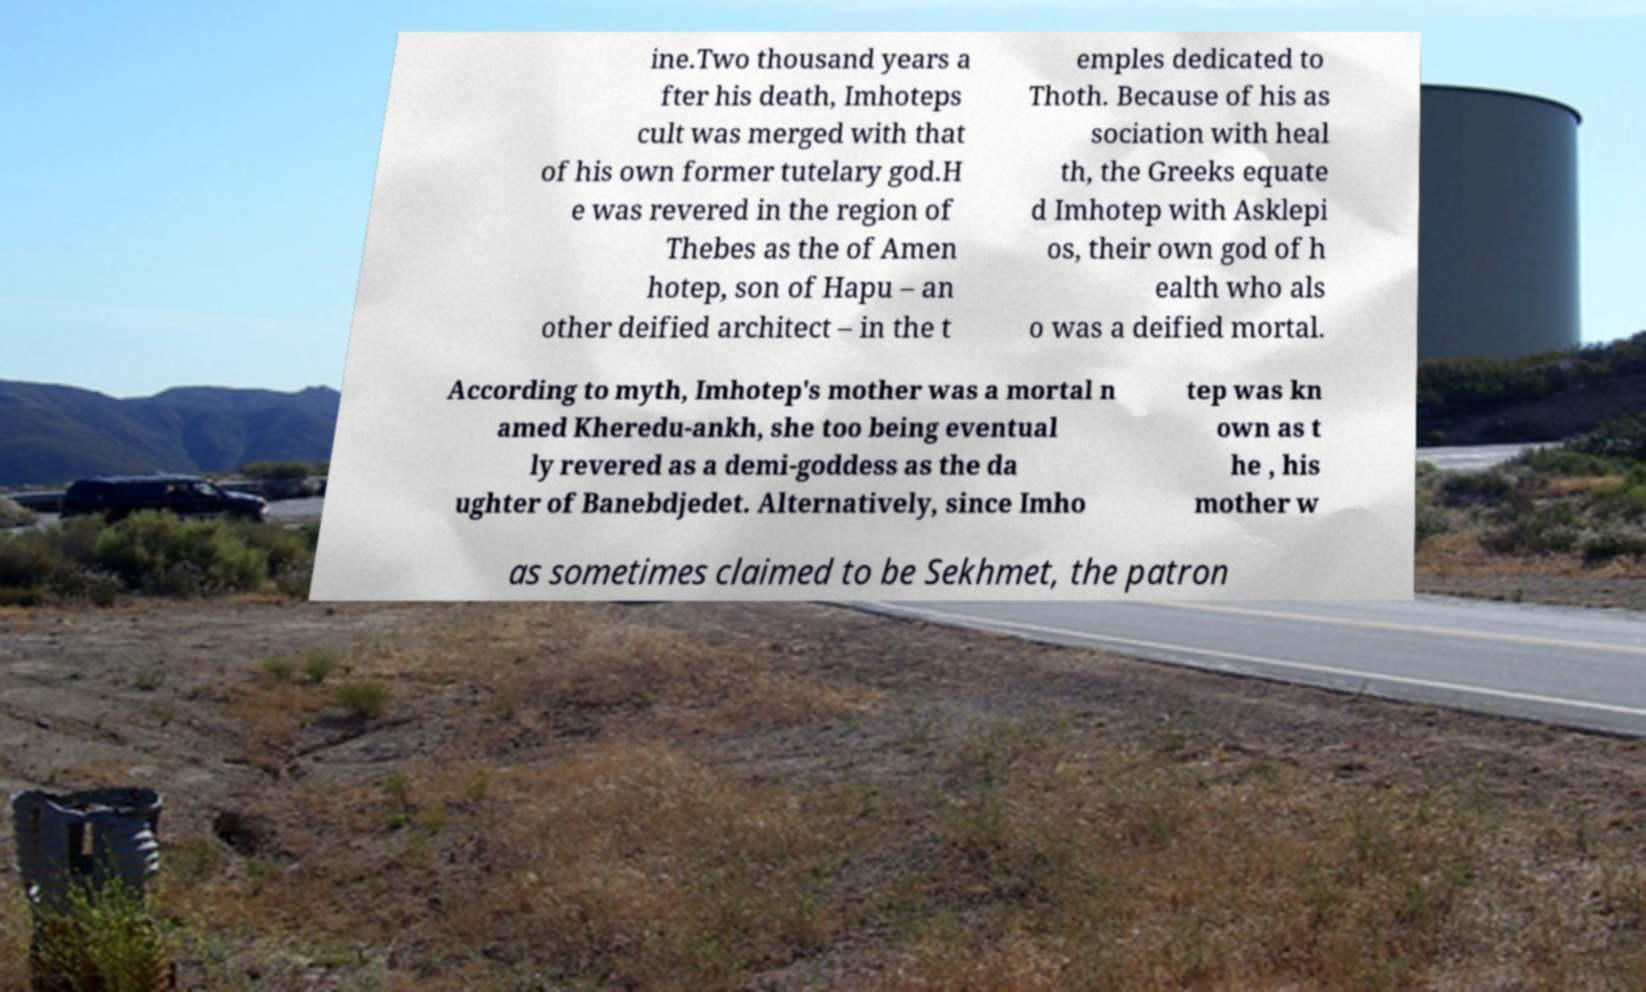Can you read and provide the text displayed in the image?This photo seems to have some interesting text. Can you extract and type it out for me? ine.Two thousand years a fter his death, Imhoteps cult was merged with that of his own former tutelary god.H e was revered in the region of Thebes as the of Amen hotep, son of Hapu – an other deified architect – in the t emples dedicated to Thoth. Because of his as sociation with heal th, the Greeks equate d Imhotep with Asklepi os, their own god of h ealth who als o was a deified mortal. According to myth, Imhotep's mother was a mortal n amed Kheredu-ankh, she too being eventual ly revered as a demi-goddess as the da ughter of Banebdjedet. Alternatively, since Imho tep was kn own as t he , his mother w as sometimes claimed to be Sekhmet, the patron 